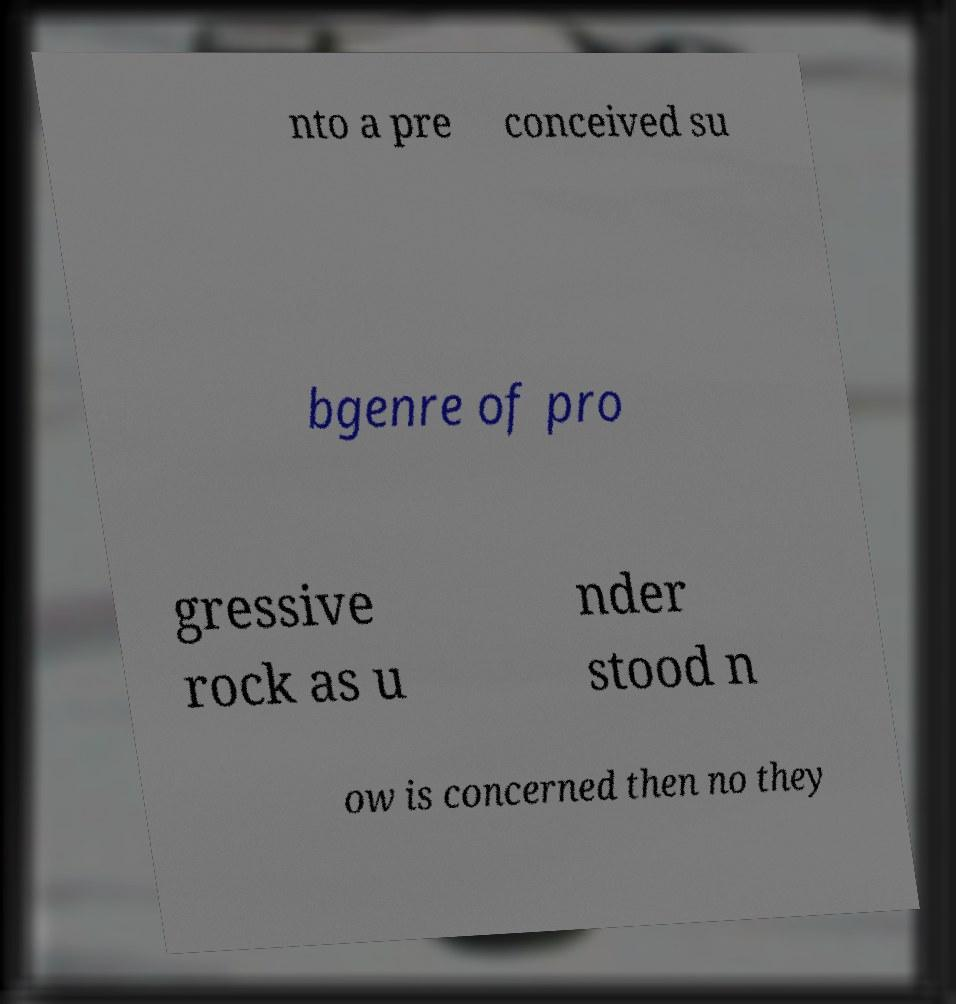Could you extract and type out the text from this image? nto a pre conceived su bgenre of pro gressive rock as u nder stood n ow is concerned then no they 